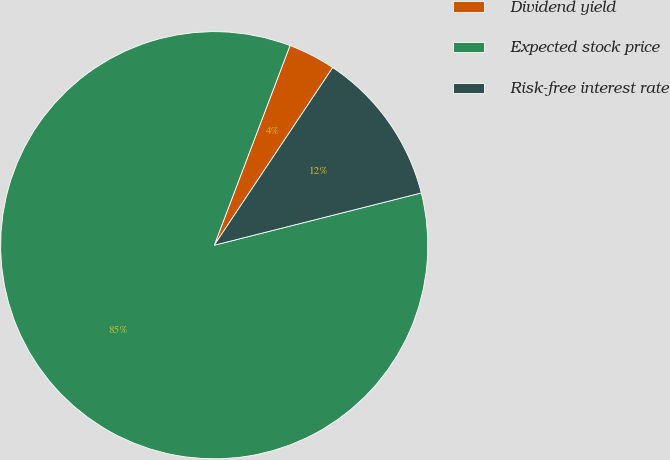Convert chart to OTSL. <chart><loc_0><loc_0><loc_500><loc_500><pie_chart><fcel>Dividend yield<fcel>Expected stock price<fcel>Risk-free interest rate<nl><fcel>3.59%<fcel>84.7%<fcel>11.7%<nl></chart> 